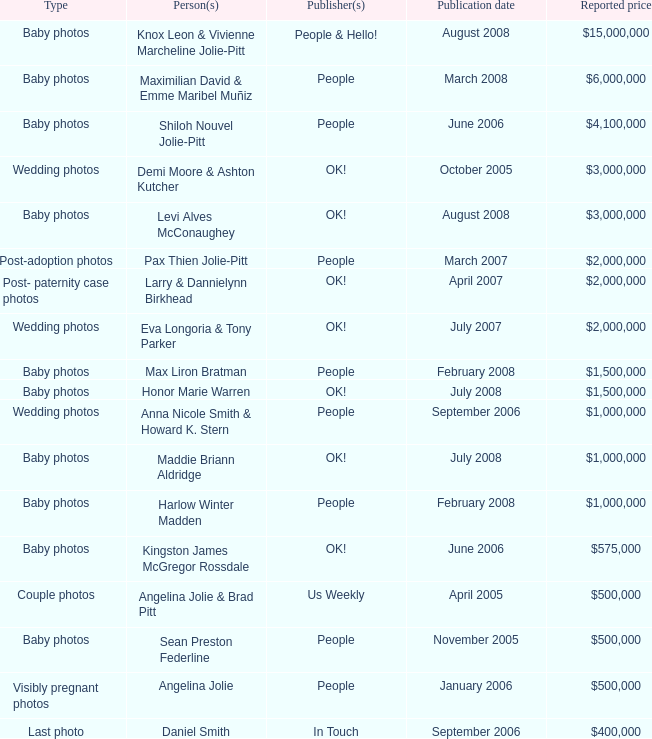What type of photos of Angelina Jolie cost $500,000? Visibly pregnant photos. 